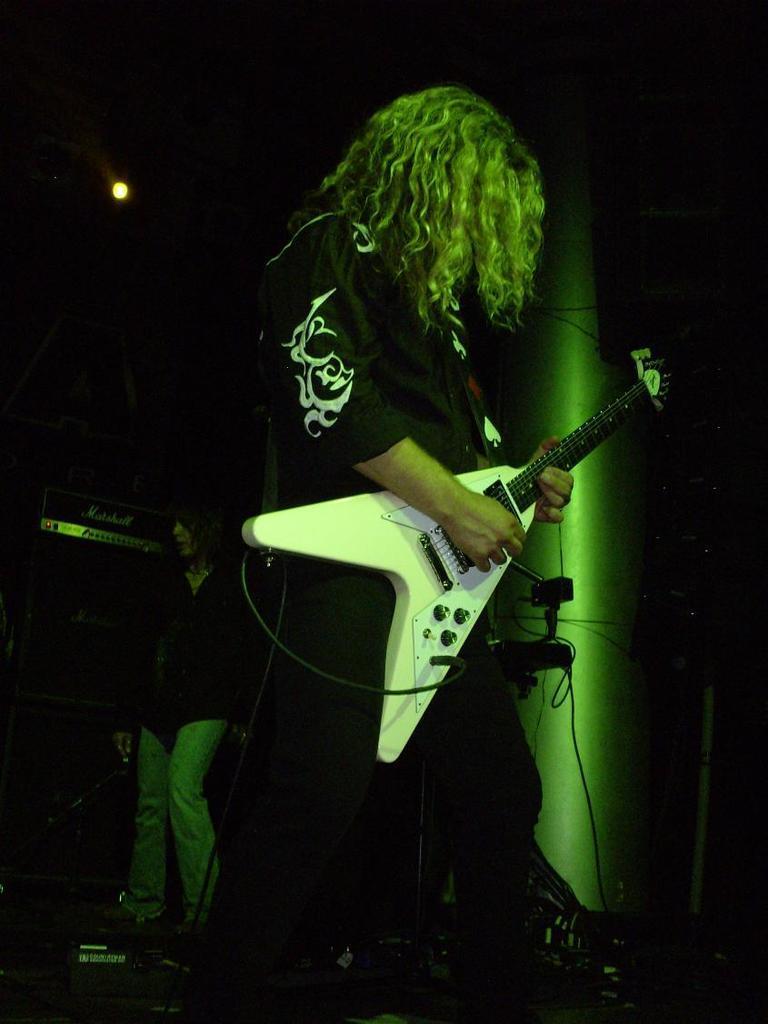How would you summarize this image in a sentence or two? In this image there is a person wearing black color shirt playing guitar. 